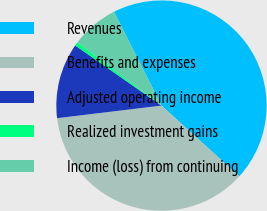<chart> <loc_0><loc_0><loc_500><loc_500><pie_chart><fcel>Revenues<fcel>Benefits and expenses<fcel>Adjusted operating income<fcel>Realized investment gains<fcel>Income (loss) from continuing<nl><fcel>44.2%<fcel>36.35%<fcel>11.6%<fcel>0.61%<fcel>7.24%<nl></chart> 